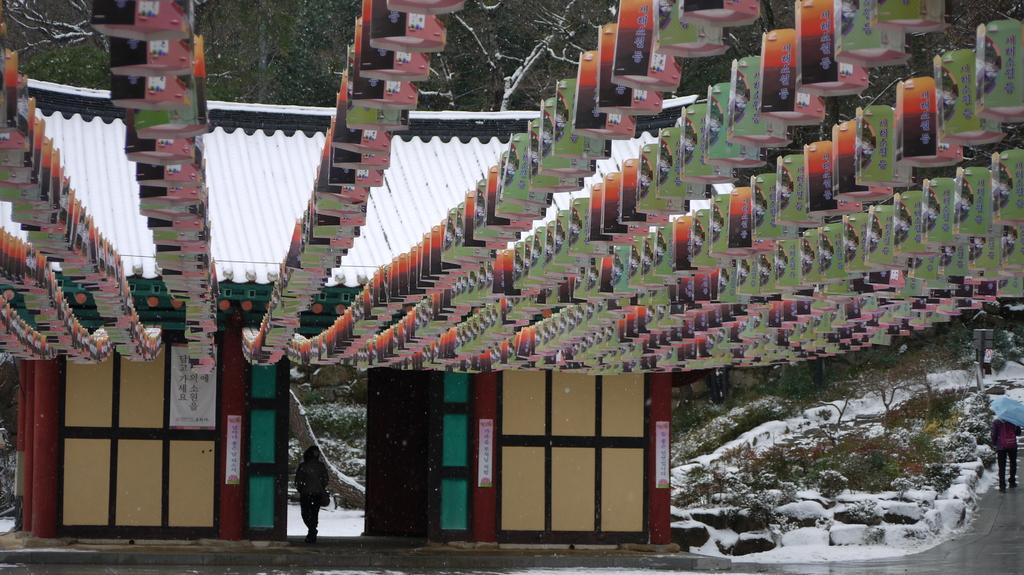Describe this image in one or two sentences. In the center of the image we can see a shed, roof, banners, door and a person is standing and wearing a bag. In the background of the image we can see the trees, boards, rocks, snow. On the right side of the image we can see a person is walking on the road and holding an umbrella and wearing a bag. At the bottom of the image we can see the road. 